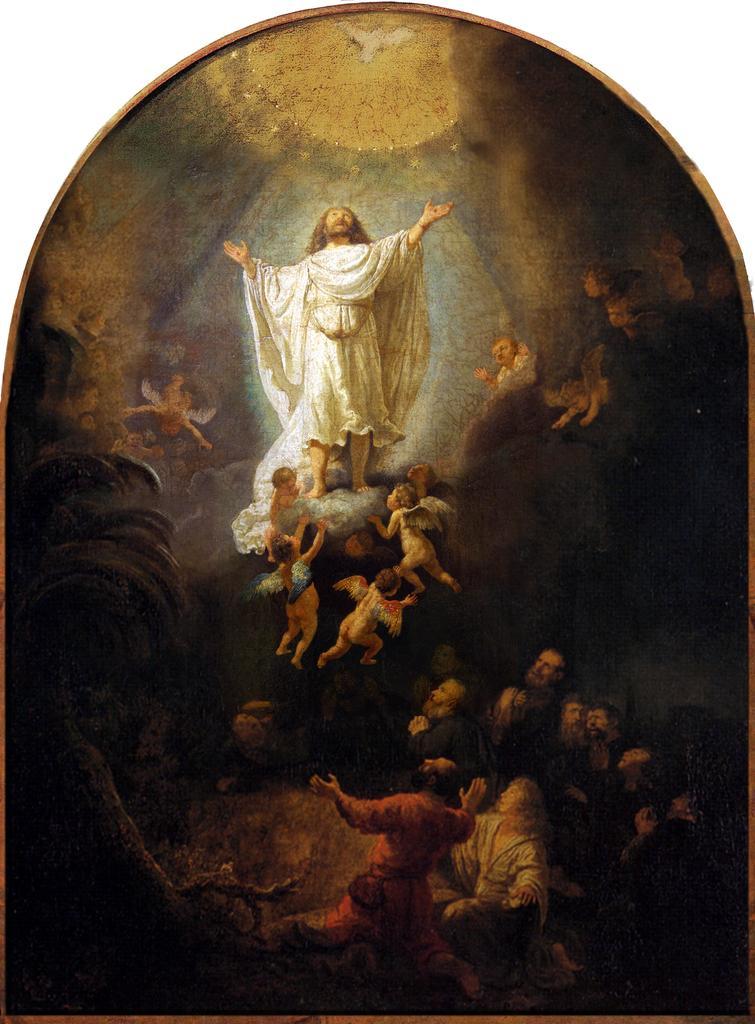Describe this image in one or two sentences. In this image, I can see a painting of people, a bird, a tree and light. There is a white background. 